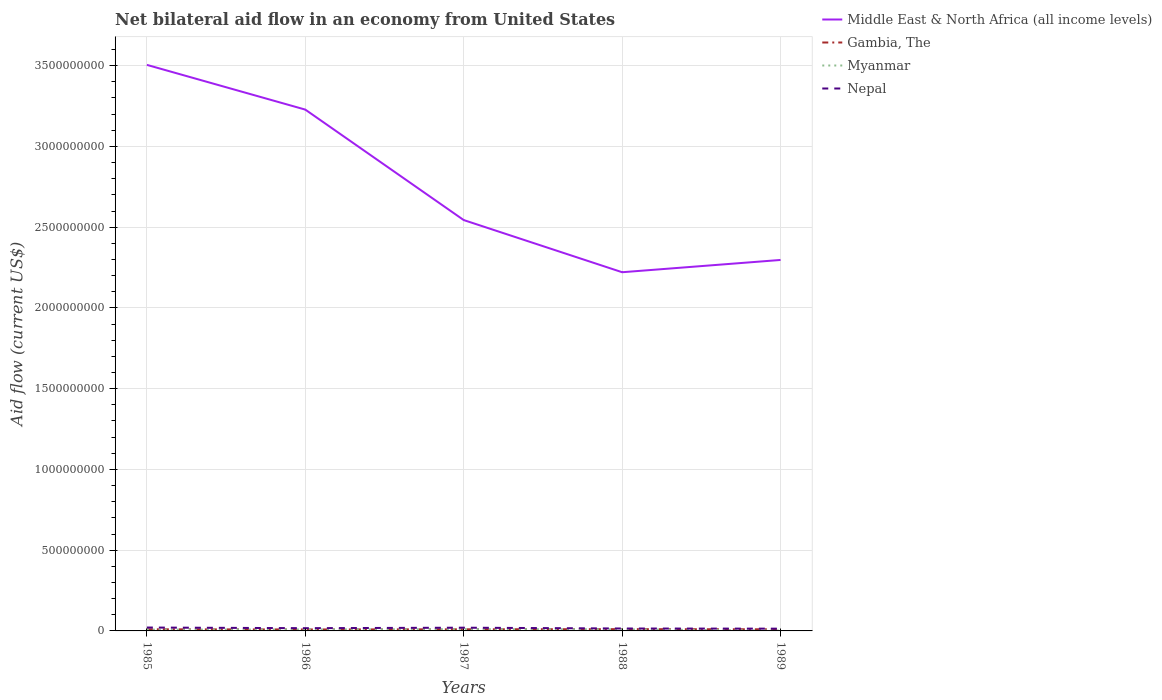Does the line corresponding to Middle East & North Africa (all income levels) intersect with the line corresponding to Myanmar?
Offer a terse response. No. Is the number of lines equal to the number of legend labels?
Your response must be concise. Yes. Across all years, what is the maximum net bilateral aid flow in Myanmar?
Keep it short and to the point. 2.00e+06. What is the total net bilateral aid flow in Nepal in the graph?
Keep it short and to the point. 4.00e+06. What is the difference between the highest and the second highest net bilateral aid flow in Myanmar?
Give a very brief answer. 9.00e+06. What is the difference between the highest and the lowest net bilateral aid flow in Middle East & North Africa (all income levels)?
Make the answer very short. 2. Is the net bilateral aid flow in Gambia, The strictly greater than the net bilateral aid flow in Nepal over the years?
Your answer should be compact. Yes. Are the values on the major ticks of Y-axis written in scientific E-notation?
Your response must be concise. No. Does the graph contain grids?
Your response must be concise. Yes. What is the title of the graph?
Your answer should be compact. Net bilateral aid flow in an economy from United States. What is the label or title of the X-axis?
Ensure brevity in your answer.  Years. What is the label or title of the Y-axis?
Make the answer very short. Aid flow (current US$). What is the Aid flow (current US$) of Middle East & North Africa (all income levels) in 1985?
Provide a short and direct response. 3.50e+09. What is the Aid flow (current US$) in Gambia, The in 1985?
Provide a short and direct response. 1.00e+07. What is the Aid flow (current US$) of Nepal in 1985?
Provide a succinct answer. 2.10e+07. What is the Aid flow (current US$) of Middle East & North Africa (all income levels) in 1986?
Provide a succinct answer. 3.23e+09. What is the Aid flow (current US$) of Gambia, The in 1986?
Keep it short and to the point. 9.00e+06. What is the Aid flow (current US$) in Myanmar in 1986?
Ensure brevity in your answer.  9.00e+06. What is the Aid flow (current US$) in Nepal in 1986?
Your answer should be very brief. 1.70e+07. What is the Aid flow (current US$) in Middle East & North Africa (all income levels) in 1987?
Offer a terse response. 2.54e+09. What is the Aid flow (current US$) of Myanmar in 1987?
Offer a terse response. 1.10e+07. What is the Aid flow (current US$) in Nepal in 1987?
Your answer should be compact. 2.00e+07. What is the Aid flow (current US$) of Middle East & North Africa (all income levels) in 1988?
Provide a short and direct response. 2.22e+09. What is the Aid flow (current US$) in Gambia, The in 1988?
Offer a very short reply. 1.10e+07. What is the Aid flow (current US$) of Myanmar in 1988?
Give a very brief answer. 1.00e+07. What is the Aid flow (current US$) in Nepal in 1988?
Provide a succinct answer. 1.50e+07. What is the Aid flow (current US$) of Middle East & North Africa (all income levels) in 1989?
Your answer should be compact. 2.30e+09. What is the Aid flow (current US$) of Nepal in 1989?
Your answer should be compact. 1.40e+07. Across all years, what is the maximum Aid flow (current US$) of Middle East & North Africa (all income levels)?
Your answer should be very brief. 3.50e+09. Across all years, what is the maximum Aid flow (current US$) in Gambia, The?
Ensure brevity in your answer.  1.10e+07. Across all years, what is the maximum Aid flow (current US$) of Myanmar?
Provide a succinct answer. 1.10e+07. Across all years, what is the maximum Aid flow (current US$) in Nepal?
Your answer should be very brief. 2.10e+07. Across all years, what is the minimum Aid flow (current US$) of Middle East & North Africa (all income levels)?
Your response must be concise. 2.22e+09. Across all years, what is the minimum Aid flow (current US$) in Gambia, The?
Ensure brevity in your answer.  9.00e+06. Across all years, what is the minimum Aid flow (current US$) in Nepal?
Keep it short and to the point. 1.40e+07. What is the total Aid flow (current US$) of Middle East & North Africa (all income levels) in the graph?
Offer a very short reply. 1.38e+1. What is the total Aid flow (current US$) in Myanmar in the graph?
Provide a succinct answer. 4.00e+07. What is the total Aid flow (current US$) in Nepal in the graph?
Your answer should be very brief. 8.70e+07. What is the difference between the Aid flow (current US$) in Middle East & North Africa (all income levels) in 1985 and that in 1986?
Provide a short and direct response. 2.77e+08. What is the difference between the Aid flow (current US$) of Gambia, The in 1985 and that in 1986?
Give a very brief answer. 1.00e+06. What is the difference between the Aid flow (current US$) of Middle East & North Africa (all income levels) in 1985 and that in 1987?
Your answer should be very brief. 9.61e+08. What is the difference between the Aid flow (current US$) of Gambia, The in 1985 and that in 1987?
Keep it short and to the point. 0. What is the difference between the Aid flow (current US$) in Myanmar in 1985 and that in 1987?
Your response must be concise. -3.00e+06. What is the difference between the Aid flow (current US$) in Nepal in 1985 and that in 1987?
Keep it short and to the point. 1.00e+06. What is the difference between the Aid flow (current US$) in Middle East & North Africa (all income levels) in 1985 and that in 1988?
Provide a short and direct response. 1.28e+09. What is the difference between the Aid flow (current US$) in Gambia, The in 1985 and that in 1988?
Provide a succinct answer. -1.00e+06. What is the difference between the Aid flow (current US$) of Myanmar in 1985 and that in 1988?
Offer a terse response. -2.00e+06. What is the difference between the Aid flow (current US$) of Nepal in 1985 and that in 1988?
Provide a succinct answer. 6.00e+06. What is the difference between the Aid flow (current US$) of Middle East & North Africa (all income levels) in 1985 and that in 1989?
Your response must be concise. 1.21e+09. What is the difference between the Aid flow (current US$) in Gambia, The in 1985 and that in 1989?
Offer a very short reply. 0. What is the difference between the Aid flow (current US$) in Middle East & North Africa (all income levels) in 1986 and that in 1987?
Give a very brief answer. 6.84e+08. What is the difference between the Aid flow (current US$) of Gambia, The in 1986 and that in 1987?
Your response must be concise. -1.00e+06. What is the difference between the Aid flow (current US$) in Myanmar in 1986 and that in 1987?
Provide a succinct answer. -2.00e+06. What is the difference between the Aid flow (current US$) of Middle East & North Africa (all income levels) in 1986 and that in 1988?
Offer a very short reply. 1.01e+09. What is the difference between the Aid flow (current US$) in Gambia, The in 1986 and that in 1988?
Offer a terse response. -2.00e+06. What is the difference between the Aid flow (current US$) in Nepal in 1986 and that in 1988?
Your response must be concise. 2.00e+06. What is the difference between the Aid flow (current US$) in Middle East & North Africa (all income levels) in 1986 and that in 1989?
Your answer should be very brief. 9.31e+08. What is the difference between the Aid flow (current US$) of Gambia, The in 1986 and that in 1989?
Ensure brevity in your answer.  -1.00e+06. What is the difference between the Aid flow (current US$) of Myanmar in 1986 and that in 1989?
Your answer should be very brief. 7.00e+06. What is the difference between the Aid flow (current US$) in Middle East & North Africa (all income levels) in 1987 and that in 1988?
Make the answer very short. 3.23e+08. What is the difference between the Aid flow (current US$) in Myanmar in 1987 and that in 1988?
Your answer should be very brief. 1.00e+06. What is the difference between the Aid flow (current US$) of Middle East & North Africa (all income levels) in 1987 and that in 1989?
Your answer should be very brief. 2.47e+08. What is the difference between the Aid flow (current US$) in Gambia, The in 1987 and that in 1989?
Ensure brevity in your answer.  0. What is the difference between the Aid flow (current US$) in Myanmar in 1987 and that in 1989?
Provide a short and direct response. 9.00e+06. What is the difference between the Aid flow (current US$) of Nepal in 1987 and that in 1989?
Keep it short and to the point. 6.00e+06. What is the difference between the Aid flow (current US$) of Middle East & North Africa (all income levels) in 1988 and that in 1989?
Offer a terse response. -7.60e+07. What is the difference between the Aid flow (current US$) in Middle East & North Africa (all income levels) in 1985 and the Aid flow (current US$) in Gambia, The in 1986?
Provide a succinct answer. 3.50e+09. What is the difference between the Aid flow (current US$) of Middle East & North Africa (all income levels) in 1985 and the Aid flow (current US$) of Myanmar in 1986?
Offer a terse response. 3.50e+09. What is the difference between the Aid flow (current US$) of Middle East & North Africa (all income levels) in 1985 and the Aid flow (current US$) of Nepal in 1986?
Your answer should be very brief. 3.49e+09. What is the difference between the Aid flow (current US$) in Gambia, The in 1985 and the Aid flow (current US$) in Myanmar in 1986?
Your answer should be very brief. 1.00e+06. What is the difference between the Aid flow (current US$) of Gambia, The in 1985 and the Aid flow (current US$) of Nepal in 1986?
Make the answer very short. -7.00e+06. What is the difference between the Aid flow (current US$) in Myanmar in 1985 and the Aid flow (current US$) in Nepal in 1986?
Make the answer very short. -9.00e+06. What is the difference between the Aid flow (current US$) in Middle East & North Africa (all income levels) in 1985 and the Aid flow (current US$) in Gambia, The in 1987?
Keep it short and to the point. 3.50e+09. What is the difference between the Aid flow (current US$) of Middle East & North Africa (all income levels) in 1985 and the Aid flow (current US$) of Myanmar in 1987?
Offer a terse response. 3.49e+09. What is the difference between the Aid flow (current US$) in Middle East & North Africa (all income levels) in 1985 and the Aid flow (current US$) in Nepal in 1987?
Your response must be concise. 3.48e+09. What is the difference between the Aid flow (current US$) of Gambia, The in 1985 and the Aid flow (current US$) of Myanmar in 1987?
Give a very brief answer. -1.00e+06. What is the difference between the Aid flow (current US$) in Gambia, The in 1985 and the Aid flow (current US$) in Nepal in 1987?
Offer a very short reply. -1.00e+07. What is the difference between the Aid flow (current US$) in Myanmar in 1985 and the Aid flow (current US$) in Nepal in 1987?
Give a very brief answer. -1.20e+07. What is the difference between the Aid flow (current US$) in Middle East & North Africa (all income levels) in 1985 and the Aid flow (current US$) in Gambia, The in 1988?
Offer a terse response. 3.49e+09. What is the difference between the Aid flow (current US$) in Middle East & North Africa (all income levels) in 1985 and the Aid flow (current US$) in Myanmar in 1988?
Provide a succinct answer. 3.50e+09. What is the difference between the Aid flow (current US$) of Middle East & North Africa (all income levels) in 1985 and the Aid flow (current US$) of Nepal in 1988?
Your response must be concise. 3.49e+09. What is the difference between the Aid flow (current US$) in Gambia, The in 1985 and the Aid flow (current US$) in Myanmar in 1988?
Your response must be concise. 0. What is the difference between the Aid flow (current US$) in Gambia, The in 1985 and the Aid flow (current US$) in Nepal in 1988?
Your answer should be compact. -5.00e+06. What is the difference between the Aid flow (current US$) in Myanmar in 1985 and the Aid flow (current US$) in Nepal in 1988?
Your answer should be compact. -7.00e+06. What is the difference between the Aid flow (current US$) of Middle East & North Africa (all income levels) in 1985 and the Aid flow (current US$) of Gambia, The in 1989?
Keep it short and to the point. 3.50e+09. What is the difference between the Aid flow (current US$) of Middle East & North Africa (all income levels) in 1985 and the Aid flow (current US$) of Myanmar in 1989?
Offer a terse response. 3.50e+09. What is the difference between the Aid flow (current US$) in Middle East & North Africa (all income levels) in 1985 and the Aid flow (current US$) in Nepal in 1989?
Ensure brevity in your answer.  3.49e+09. What is the difference between the Aid flow (current US$) in Gambia, The in 1985 and the Aid flow (current US$) in Nepal in 1989?
Ensure brevity in your answer.  -4.00e+06. What is the difference between the Aid flow (current US$) of Myanmar in 1985 and the Aid flow (current US$) of Nepal in 1989?
Provide a succinct answer. -6.00e+06. What is the difference between the Aid flow (current US$) of Middle East & North Africa (all income levels) in 1986 and the Aid flow (current US$) of Gambia, The in 1987?
Keep it short and to the point. 3.22e+09. What is the difference between the Aid flow (current US$) of Middle East & North Africa (all income levels) in 1986 and the Aid flow (current US$) of Myanmar in 1987?
Give a very brief answer. 3.22e+09. What is the difference between the Aid flow (current US$) in Middle East & North Africa (all income levels) in 1986 and the Aid flow (current US$) in Nepal in 1987?
Your response must be concise. 3.21e+09. What is the difference between the Aid flow (current US$) in Gambia, The in 1986 and the Aid flow (current US$) in Myanmar in 1987?
Offer a terse response. -2.00e+06. What is the difference between the Aid flow (current US$) of Gambia, The in 1986 and the Aid flow (current US$) of Nepal in 1987?
Your response must be concise. -1.10e+07. What is the difference between the Aid flow (current US$) of Myanmar in 1986 and the Aid flow (current US$) of Nepal in 1987?
Your response must be concise. -1.10e+07. What is the difference between the Aid flow (current US$) in Middle East & North Africa (all income levels) in 1986 and the Aid flow (current US$) in Gambia, The in 1988?
Offer a terse response. 3.22e+09. What is the difference between the Aid flow (current US$) in Middle East & North Africa (all income levels) in 1986 and the Aid flow (current US$) in Myanmar in 1988?
Give a very brief answer. 3.22e+09. What is the difference between the Aid flow (current US$) of Middle East & North Africa (all income levels) in 1986 and the Aid flow (current US$) of Nepal in 1988?
Make the answer very short. 3.21e+09. What is the difference between the Aid flow (current US$) in Gambia, The in 1986 and the Aid flow (current US$) in Nepal in 1988?
Make the answer very short. -6.00e+06. What is the difference between the Aid flow (current US$) in Myanmar in 1986 and the Aid flow (current US$) in Nepal in 1988?
Keep it short and to the point. -6.00e+06. What is the difference between the Aid flow (current US$) of Middle East & North Africa (all income levels) in 1986 and the Aid flow (current US$) of Gambia, The in 1989?
Make the answer very short. 3.22e+09. What is the difference between the Aid flow (current US$) of Middle East & North Africa (all income levels) in 1986 and the Aid flow (current US$) of Myanmar in 1989?
Provide a short and direct response. 3.23e+09. What is the difference between the Aid flow (current US$) in Middle East & North Africa (all income levels) in 1986 and the Aid flow (current US$) in Nepal in 1989?
Ensure brevity in your answer.  3.21e+09. What is the difference between the Aid flow (current US$) in Gambia, The in 1986 and the Aid flow (current US$) in Myanmar in 1989?
Ensure brevity in your answer.  7.00e+06. What is the difference between the Aid flow (current US$) in Gambia, The in 1986 and the Aid flow (current US$) in Nepal in 1989?
Offer a very short reply. -5.00e+06. What is the difference between the Aid flow (current US$) of Myanmar in 1986 and the Aid flow (current US$) of Nepal in 1989?
Keep it short and to the point. -5.00e+06. What is the difference between the Aid flow (current US$) of Middle East & North Africa (all income levels) in 1987 and the Aid flow (current US$) of Gambia, The in 1988?
Your response must be concise. 2.53e+09. What is the difference between the Aid flow (current US$) of Middle East & North Africa (all income levels) in 1987 and the Aid flow (current US$) of Myanmar in 1988?
Provide a short and direct response. 2.53e+09. What is the difference between the Aid flow (current US$) in Middle East & North Africa (all income levels) in 1987 and the Aid flow (current US$) in Nepal in 1988?
Ensure brevity in your answer.  2.53e+09. What is the difference between the Aid flow (current US$) in Gambia, The in 1987 and the Aid flow (current US$) in Nepal in 1988?
Your response must be concise. -5.00e+06. What is the difference between the Aid flow (current US$) in Myanmar in 1987 and the Aid flow (current US$) in Nepal in 1988?
Your answer should be compact. -4.00e+06. What is the difference between the Aid flow (current US$) of Middle East & North Africa (all income levels) in 1987 and the Aid flow (current US$) of Gambia, The in 1989?
Provide a short and direct response. 2.53e+09. What is the difference between the Aid flow (current US$) of Middle East & North Africa (all income levels) in 1987 and the Aid flow (current US$) of Myanmar in 1989?
Your answer should be compact. 2.54e+09. What is the difference between the Aid flow (current US$) in Middle East & North Africa (all income levels) in 1987 and the Aid flow (current US$) in Nepal in 1989?
Make the answer very short. 2.53e+09. What is the difference between the Aid flow (current US$) in Middle East & North Africa (all income levels) in 1988 and the Aid flow (current US$) in Gambia, The in 1989?
Give a very brief answer. 2.21e+09. What is the difference between the Aid flow (current US$) in Middle East & North Africa (all income levels) in 1988 and the Aid flow (current US$) in Myanmar in 1989?
Provide a short and direct response. 2.22e+09. What is the difference between the Aid flow (current US$) of Middle East & North Africa (all income levels) in 1988 and the Aid flow (current US$) of Nepal in 1989?
Offer a very short reply. 2.21e+09. What is the difference between the Aid flow (current US$) of Gambia, The in 1988 and the Aid flow (current US$) of Myanmar in 1989?
Provide a short and direct response. 9.00e+06. What is the average Aid flow (current US$) of Middle East & North Africa (all income levels) per year?
Offer a very short reply. 2.76e+09. What is the average Aid flow (current US$) of Myanmar per year?
Offer a very short reply. 8.00e+06. What is the average Aid flow (current US$) of Nepal per year?
Offer a very short reply. 1.74e+07. In the year 1985, what is the difference between the Aid flow (current US$) of Middle East & North Africa (all income levels) and Aid flow (current US$) of Gambia, The?
Your answer should be very brief. 3.50e+09. In the year 1985, what is the difference between the Aid flow (current US$) of Middle East & North Africa (all income levels) and Aid flow (current US$) of Myanmar?
Give a very brief answer. 3.50e+09. In the year 1985, what is the difference between the Aid flow (current US$) of Middle East & North Africa (all income levels) and Aid flow (current US$) of Nepal?
Your answer should be very brief. 3.48e+09. In the year 1985, what is the difference between the Aid flow (current US$) in Gambia, The and Aid flow (current US$) in Myanmar?
Your answer should be very brief. 2.00e+06. In the year 1985, what is the difference between the Aid flow (current US$) in Gambia, The and Aid flow (current US$) in Nepal?
Offer a very short reply. -1.10e+07. In the year 1985, what is the difference between the Aid flow (current US$) of Myanmar and Aid flow (current US$) of Nepal?
Ensure brevity in your answer.  -1.30e+07. In the year 1986, what is the difference between the Aid flow (current US$) in Middle East & North Africa (all income levels) and Aid flow (current US$) in Gambia, The?
Your answer should be very brief. 3.22e+09. In the year 1986, what is the difference between the Aid flow (current US$) of Middle East & North Africa (all income levels) and Aid flow (current US$) of Myanmar?
Your response must be concise. 3.22e+09. In the year 1986, what is the difference between the Aid flow (current US$) in Middle East & North Africa (all income levels) and Aid flow (current US$) in Nepal?
Offer a very short reply. 3.21e+09. In the year 1986, what is the difference between the Aid flow (current US$) in Gambia, The and Aid flow (current US$) in Myanmar?
Give a very brief answer. 0. In the year 1986, what is the difference between the Aid flow (current US$) of Gambia, The and Aid flow (current US$) of Nepal?
Give a very brief answer. -8.00e+06. In the year 1986, what is the difference between the Aid flow (current US$) of Myanmar and Aid flow (current US$) of Nepal?
Ensure brevity in your answer.  -8.00e+06. In the year 1987, what is the difference between the Aid flow (current US$) of Middle East & North Africa (all income levels) and Aid flow (current US$) of Gambia, The?
Provide a short and direct response. 2.53e+09. In the year 1987, what is the difference between the Aid flow (current US$) of Middle East & North Africa (all income levels) and Aid flow (current US$) of Myanmar?
Keep it short and to the point. 2.53e+09. In the year 1987, what is the difference between the Aid flow (current US$) in Middle East & North Africa (all income levels) and Aid flow (current US$) in Nepal?
Offer a terse response. 2.52e+09. In the year 1987, what is the difference between the Aid flow (current US$) of Gambia, The and Aid flow (current US$) of Nepal?
Offer a terse response. -1.00e+07. In the year 1987, what is the difference between the Aid flow (current US$) of Myanmar and Aid flow (current US$) of Nepal?
Offer a terse response. -9.00e+06. In the year 1988, what is the difference between the Aid flow (current US$) in Middle East & North Africa (all income levels) and Aid flow (current US$) in Gambia, The?
Keep it short and to the point. 2.21e+09. In the year 1988, what is the difference between the Aid flow (current US$) in Middle East & North Africa (all income levels) and Aid flow (current US$) in Myanmar?
Your answer should be compact. 2.21e+09. In the year 1988, what is the difference between the Aid flow (current US$) of Middle East & North Africa (all income levels) and Aid flow (current US$) of Nepal?
Give a very brief answer. 2.21e+09. In the year 1988, what is the difference between the Aid flow (current US$) of Gambia, The and Aid flow (current US$) of Myanmar?
Ensure brevity in your answer.  1.00e+06. In the year 1988, what is the difference between the Aid flow (current US$) in Gambia, The and Aid flow (current US$) in Nepal?
Give a very brief answer. -4.00e+06. In the year 1988, what is the difference between the Aid flow (current US$) in Myanmar and Aid flow (current US$) in Nepal?
Keep it short and to the point. -5.00e+06. In the year 1989, what is the difference between the Aid flow (current US$) in Middle East & North Africa (all income levels) and Aid flow (current US$) in Gambia, The?
Keep it short and to the point. 2.29e+09. In the year 1989, what is the difference between the Aid flow (current US$) in Middle East & North Africa (all income levels) and Aid flow (current US$) in Myanmar?
Make the answer very short. 2.30e+09. In the year 1989, what is the difference between the Aid flow (current US$) in Middle East & North Africa (all income levels) and Aid flow (current US$) in Nepal?
Offer a terse response. 2.28e+09. In the year 1989, what is the difference between the Aid flow (current US$) in Gambia, The and Aid flow (current US$) in Nepal?
Your answer should be very brief. -4.00e+06. In the year 1989, what is the difference between the Aid flow (current US$) in Myanmar and Aid flow (current US$) in Nepal?
Give a very brief answer. -1.20e+07. What is the ratio of the Aid flow (current US$) of Middle East & North Africa (all income levels) in 1985 to that in 1986?
Provide a short and direct response. 1.09. What is the ratio of the Aid flow (current US$) in Myanmar in 1985 to that in 1986?
Provide a succinct answer. 0.89. What is the ratio of the Aid flow (current US$) in Nepal in 1985 to that in 1986?
Provide a succinct answer. 1.24. What is the ratio of the Aid flow (current US$) of Middle East & North Africa (all income levels) in 1985 to that in 1987?
Your answer should be compact. 1.38. What is the ratio of the Aid flow (current US$) in Myanmar in 1985 to that in 1987?
Give a very brief answer. 0.73. What is the ratio of the Aid flow (current US$) of Middle East & North Africa (all income levels) in 1985 to that in 1988?
Make the answer very short. 1.58. What is the ratio of the Aid flow (current US$) in Gambia, The in 1985 to that in 1988?
Offer a very short reply. 0.91. What is the ratio of the Aid flow (current US$) in Myanmar in 1985 to that in 1988?
Provide a succinct answer. 0.8. What is the ratio of the Aid flow (current US$) in Middle East & North Africa (all income levels) in 1985 to that in 1989?
Your response must be concise. 1.53. What is the ratio of the Aid flow (current US$) of Gambia, The in 1985 to that in 1989?
Ensure brevity in your answer.  1. What is the ratio of the Aid flow (current US$) in Myanmar in 1985 to that in 1989?
Offer a terse response. 4. What is the ratio of the Aid flow (current US$) in Middle East & North Africa (all income levels) in 1986 to that in 1987?
Provide a short and direct response. 1.27. What is the ratio of the Aid flow (current US$) of Myanmar in 1986 to that in 1987?
Offer a terse response. 0.82. What is the ratio of the Aid flow (current US$) in Nepal in 1986 to that in 1987?
Make the answer very short. 0.85. What is the ratio of the Aid flow (current US$) of Middle East & North Africa (all income levels) in 1986 to that in 1988?
Offer a terse response. 1.45. What is the ratio of the Aid flow (current US$) of Gambia, The in 1986 to that in 1988?
Give a very brief answer. 0.82. What is the ratio of the Aid flow (current US$) in Myanmar in 1986 to that in 1988?
Give a very brief answer. 0.9. What is the ratio of the Aid flow (current US$) of Nepal in 1986 to that in 1988?
Give a very brief answer. 1.13. What is the ratio of the Aid flow (current US$) of Middle East & North Africa (all income levels) in 1986 to that in 1989?
Offer a very short reply. 1.41. What is the ratio of the Aid flow (current US$) of Gambia, The in 1986 to that in 1989?
Offer a terse response. 0.9. What is the ratio of the Aid flow (current US$) in Nepal in 1986 to that in 1989?
Provide a short and direct response. 1.21. What is the ratio of the Aid flow (current US$) of Middle East & North Africa (all income levels) in 1987 to that in 1988?
Offer a very short reply. 1.15. What is the ratio of the Aid flow (current US$) in Gambia, The in 1987 to that in 1988?
Your answer should be very brief. 0.91. What is the ratio of the Aid flow (current US$) in Myanmar in 1987 to that in 1988?
Provide a succinct answer. 1.1. What is the ratio of the Aid flow (current US$) of Nepal in 1987 to that in 1988?
Your answer should be compact. 1.33. What is the ratio of the Aid flow (current US$) in Middle East & North Africa (all income levels) in 1987 to that in 1989?
Make the answer very short. 1.11. What is the ratio of the Aid flow (current US$) of Gambia, The in 1987 to that in 1989?
Provide a succinct answer. 1. What is the ratio of the Aid flow (current US$) of Nepal in 1987 to that in 1989?
Ensure brevity in your answer.  1.43. What is the ratio of the Aid flow (current US$) of Middle East & North Africa (all income levels) in 1988 to that in 1989?
Ensure brevity in your answer.  0.97. What is the ratio of the Aid flow (current US$) of Gambia, The in 1988 to that in 1989?
Provide a short and direct response. 1.1. What is the ratio of the Aid flow (current US$) in Myanmar in 1988 to that in 1989?
Offer a terse response. 5. What is the ratio of the Aid flow (current US$) of Nepal in 1988 to that in 1989?
Your answer should be very brief. 1.07. What is the difference between the highest and the second highest Aid flow (current US$) in Middle East & North Africa (all income levels)?
Keep it short and to the point. 2.77e+08. What is the difference between the highest and the second highest Aid flow (current US$) in Gambia, The?
Your answer should be compact. 1.00e+06. What is the difference between the highest and the second highest Aid flow (current US$) in Myanmar?
Ensure brevity in your answer.  1.00e+06. What is the difference between the highest and the lowest Aid flow (current US$) of Middle East & North Africa (all income levels)?
Your answer should be compact. 1.28e+09. What is the difference between the highest and the lowest Aid flow (current US$) of Myanmar?
Your answer should be very brief. 9.00e+06. What is the difference between the highest and the lowest Aid flow (current US$) in Nepal?
Your response must be concise. 7.00e+06. 